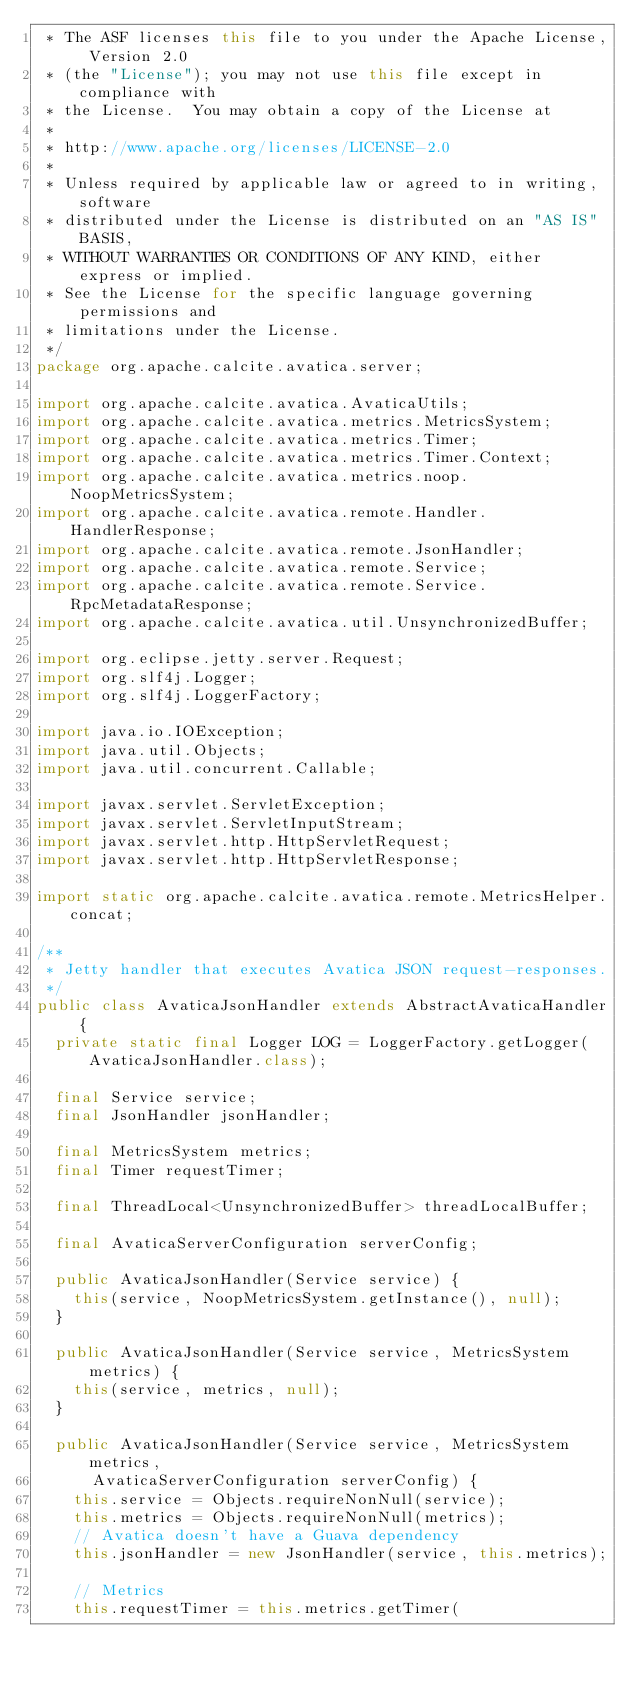Convert code to text. <code><loc_0><loc_0><loc_500><loc_500><_Java_> * The ASF licenses this file to you under the Apache License, Version 2.0
 * (the "License"); you may not use this file except in compliance with
 * the License.  You may obtain a copy of the License at
 *
 * http://www.apache.org/licenses/LICENSE-2.0
 *
 * Unless required by applicable law or agreed to in writing, software
 * distributed under the License is distributed on an "AS IS" BASIS,
 * WITHOUT WARRANTIES OR CONDITIONS OF ANY KIND, either express or implied.
 * See the License for the specific language governing permissions and
 * limitations under the License.
 */
package org.apache.calcite.avatica.server;

import org.apache.calcite.avatica.AvaticaUtils;
import org.apache.calcite.avatica.metrics.MetricsSystem;
import org.apache.calcite.avatica.metrics.Timer;
import org.apache.calcite.avatica.metrics.Timer.Context;
import org.apache.calcite.avatica.metrics.noop.NoopMetricsSystem;
import org.apache.calcite.avatica.remote.Handler.HandlerResponse;
import org.apache.calcite.avatica.remote.JsonHandler;
import org.apache.calcite.avatica.remote.Service;
import org.apache.calcite.avatica.remote.Service.RpcMetadataResponse;
import org.apache.calcite.avatica.util.UnsynchronizedBuffer;

import org.eclipse.jetty.server.Request;
import org.slf4j.Logger;
import org.slf4j.LoggerFactory;

import java.io.IOException;
import java.util.Objects;
import java.util.concurrent.Callable;

import javax.servlet.ServletException;
import javax.servlet.ServletInputStream;
import javax.servlet.http.HttpServletRequest;
import javax.servlet.http.HttpServletResponse;

import static org.apache.calcite.avatica.remote.MetricsHelper.concat;

/**
 * Jetty handler that executes Avatica JSON request-responses.
 */
public class AvaticaJsonHandler extends AbstractAvaticaHandler {
  private static final Logger LOG = LoggerFactory.getLogger(AvaticaJsonHandler.class);

  final Service service;
  final JsonHandler jsonHandler;

  final MetricsSystem metrics;
  final Timer requestTimer;

  final ThreadLocal<UnsynchronizedBuffer> threadLocalBuffer;

  final AvaticaServerConfiguration serverConfig;

  public AvaticaJsonHandler(Service service) {
    this(service, NoopMetricsSystem.getInstance(), null);
  }

  public AvaticaJsonHandler(Service service, MetricsSystem metrics) {
    this(service, metrics, null);
  }

  public AvaticaJsonHandler(Service service, MetricsSystem metrics,
      AvaticaServerConfiguration serverConfig) {
    this.service = Objects.requireNonNull(service);
    this.metrics = Objects.requireNonNull(metrics);
    // Avatica doesn't have a Guava dependency
    this.jsonHandler = new JsonHandler(service, this.metrics);

    // Metrics
    this.requestTimer = this.metrics.getTimer(</code> 